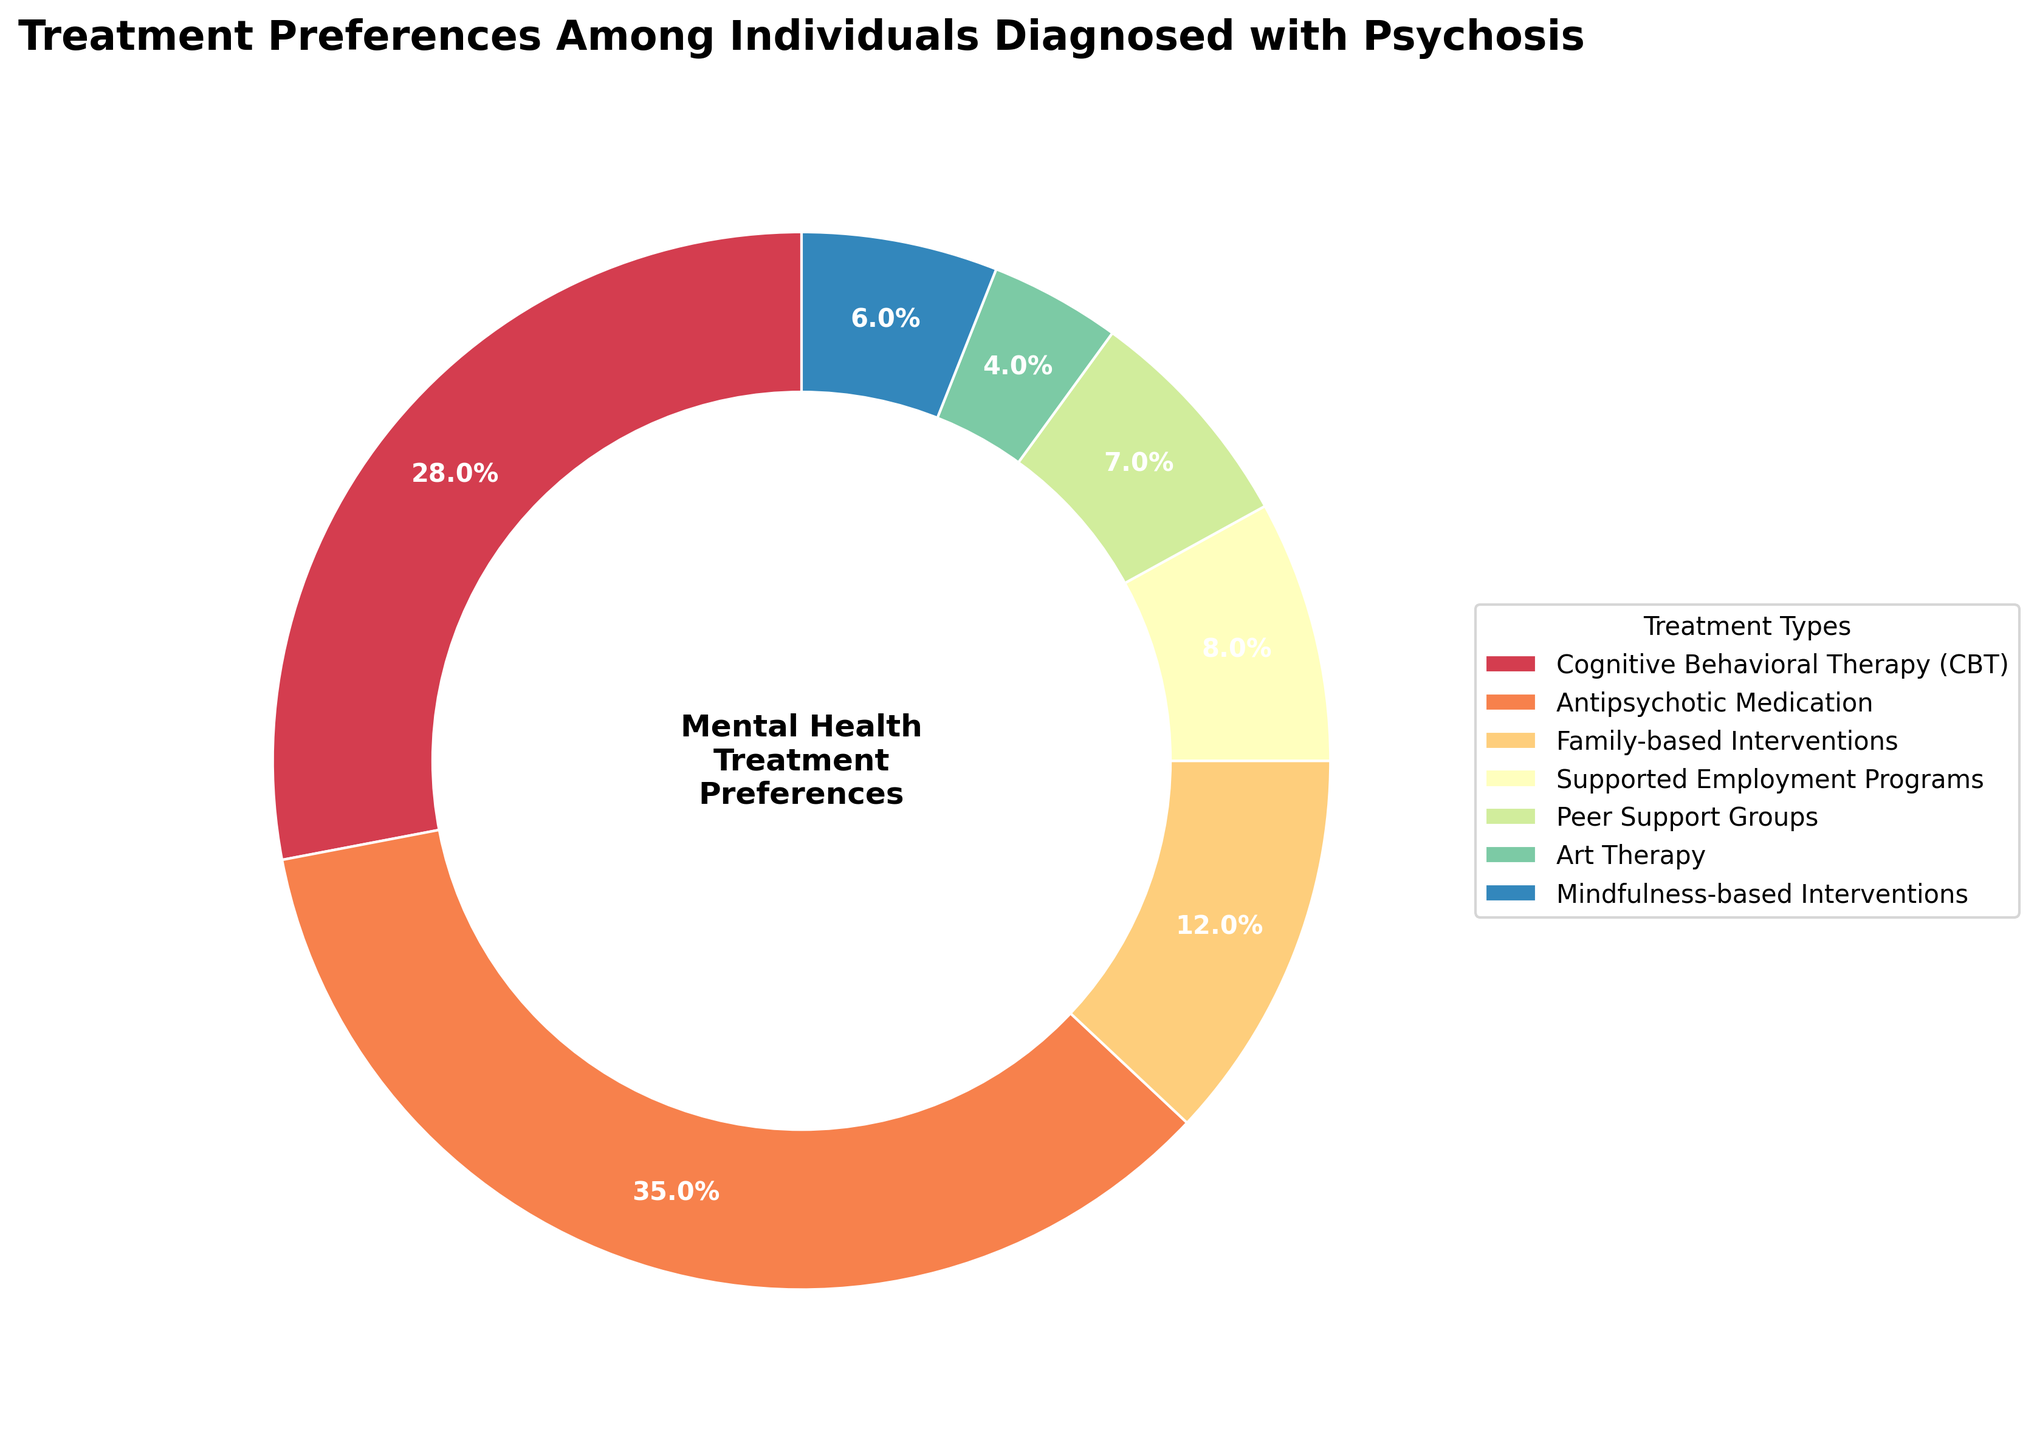What is the most preferred treatment method among individuals diagnosed with psychosis? The pie chart shows that Antipsychotic Medication has the largest slice, suggesting it is the most preferred treatment method.
Answer: Antipsychotic Medication Which treatment method is least preferred among individuals diagnosed with psychosis? The smallest slice in the pie chart corresponds to Art Therapy, indicating it is the least preferred treatment method.
Answer: Art Therapy How much more preferred is Cognitive Behavioral Therapy compared to Peer Support Groups? Cognitive Behavioral Therapy has 28% and Peer Support Groups have 7%. The difference is 28% - 7% = 21%.
Answer: 21% What is the total percentage of individuals preferring either Supported Employment Programs or Mindfulness-based Interventions? Supported Employment Programs have 8% and Mindfulness-based Interventions have 6%. The total percentage is 8% + 6% = 14%.
Answer: 14% Which treatment options have a smaller preference than Family-based Interventions? The percentages assigned to Family-based Interventions are 12%. Treatments with smaller percentages are Supported Employment Programs (8%), Peer Support Groups (7%), Art Therapy (4%), and Mindfulness-based Interventions (6%).
Answer: Supported Employment Programs, Peer Support Groups, Art Therapy, Mindfulness-based Interventions What is the combined preference for family-based and peer support treatments? Family-based Interventions account for 12% and Peer Support Groups for 7%. Their combined preference is 12% + 7% = 19%.
Answer: 19% How does the preference for Cognitive Behavioral Therapy compare to that for Mindfulness-based Interventions? Cognitive Behavioral Therapy has a preference of 28% while Mindfulness-based Interventions have a preference of 6%. Since 28% is greater than 6%, Cognitive Behavioral Therapy is more preferred.
Answer: Cognitive Behavioral Therapy is more preferred By what percentage does preference for Antipsychotic Medication exceed that of Supported Employment Programs? Antipsychotic Medication has a preference of 35% and Supported Employment Programs have 8%. The difference is 35% - 8% = 27%.
Answer: 27% What is the difference in the total percentage of individuals preferring Cognitive Behavioral Therapy and Antipsychotic Medication combined compared to all other methods? Combined, Cognitive Behavioral Therapy and Antipsychotic Medication make up 28% + 35% = 63%. All other methods combined make up 100% - 63% = 37%. The difference is 63% - 37% = 26%.
Answer: 26% 